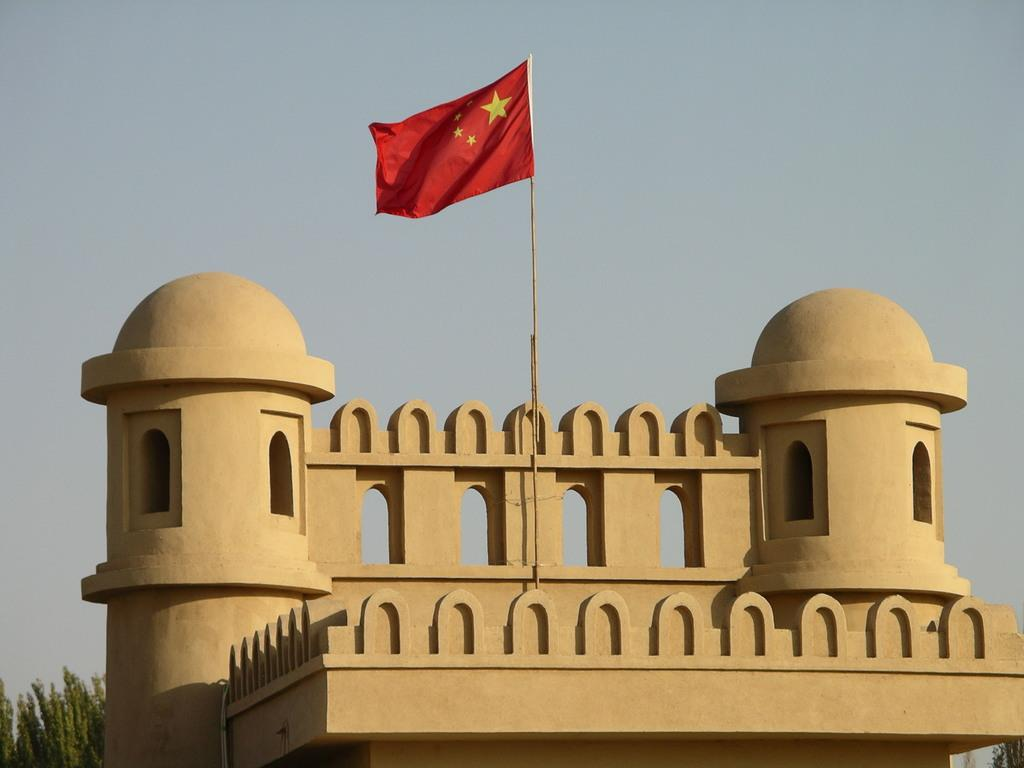What type of structure is present in the image? There is a building in the image. What other natural elements can be seen in the image? There are trees in the image. What can be seen near the building? There is a red and yellow color flag near the building. What is visible in the background of the image? The sky is visible in the background of the image. What songs are being sung by the trees in the image? The trees in the image do not sing songs; they are natural elements and do not have the ability to sing. 